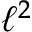Convert formula to latex. <formula><loc_0><loc_0><loc_500><loc_500>\ell ^ { 2 }</formula> 